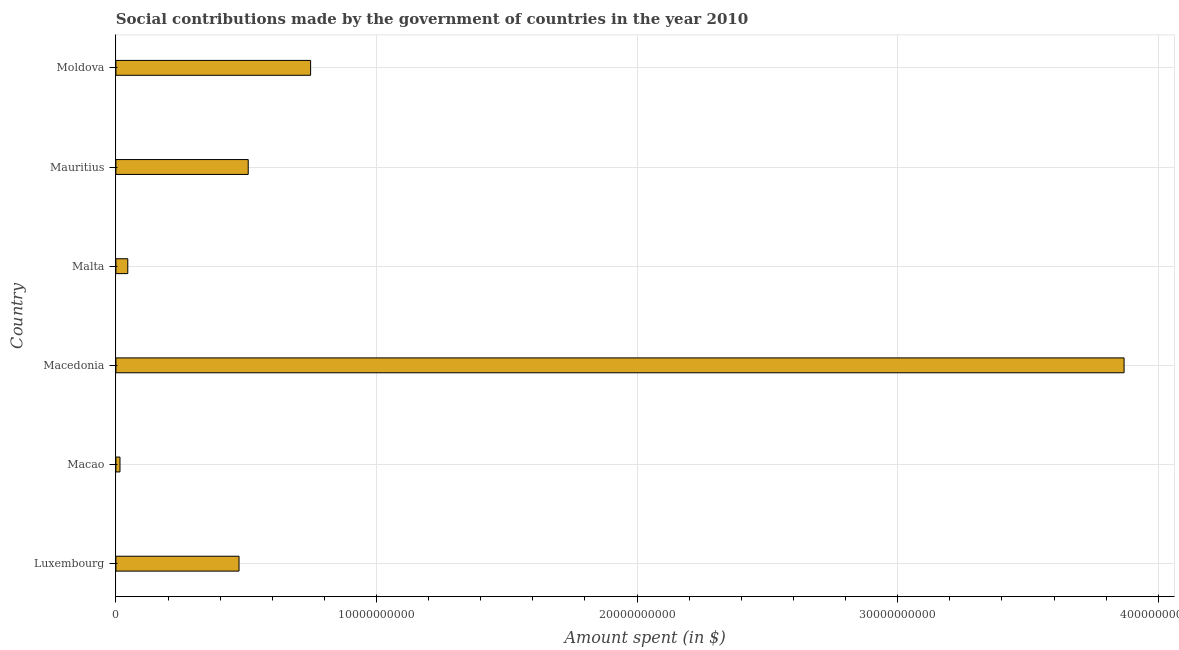What is the title of the graph?
Provide a succinct answer. Social contributions made by the government of countries in the year 2010. What is the label or title of the X-axis?
Keep it short and to the point. Amount spent (in $). What is the label or title of the Y-axis?
Give a very brief answer. Country. What is the amount spent in making social contributions in Malta?
Offer a terse response. 4.56e+08. Across all countries, what is the maximum amount spent in making social contributions?
Your answer should be very brief. 3.87e+1. Across all countries, what is the minimum amount spent in making social contributions?
Keep it short and to the point. 1.57e+08. In which country was the amount spent in making social contributions maximum?
Offer a terse response. Macedonia. In which country was the amount spent in making social contributions minimum?
Your answer should be compact. Macao. What is the sum of the amount spent in making social contributions?
Offer a terse response. 5.66e+1. What is the difference between the amount spent in making social contributions in Macao and Malta?
Offer a terse response. -2.99e+08. What is the average amount spent in making social contributions per country?
Provide a short and direct response. 9.43e+09. What is the median amount spent in making social contributions?
Offer a terse response. 4.90e+09. In how many countries, is the amount spent in making social contributions greater than 28000000000 $?
Give a very brief answer. 1. What is the ratio of the amount spent in making social contributions in Mauritius to that in Moldova?
Ensure brevity in your answer.  0.68. What is the difference between the highest and the second highest amount spent in making social contributions?
Offer a terse response. 3.12e+1. Is the sum of the amount spent in making social contributions in Luxembourg and Macedonia greater than the maximum amount spent in making social contributions across all countries?
Give a very brief answer. Yes. What is the difference between the highest and the lowest amount spent in making social contributions?
Give a very brief answer. 3.85e+1. How many countries are there in the graph?
Make the answer very short. 6. What is the Amount spent (in $) of Luxembourg?
Provide a short and direct response. 4.73e+09. What is the Amount spent (in $) of Macao?
Provide a succinct answer. 1.57e+08. What is the Amount spent (in $) in Macedonia?
Your answer should be very brief. 3.87e+1. What is the Amount spent (in $) of Malta?
Provide a short and direct response. 4.56e+08. What is the Amount spent (in $) of Mauritius?
Offer a very short reply. 5.08e+09. What is the Amount spent (in $) of Moldova?
Offer a terse response. 7.47e+09. What is the difference between the Amount spent (in $) in Luxembourg and Macao?
Provide a short and direct response. 4.57e+09. What is the difference between the Amount spent (in $) in Luxembourg and Macedonia?
Make the answer very short. -3.40e+1. What is the difference between the Amount spent (in $) in Luxembourg and Malta?
Make the answer very short. 4.27e+09. What is the difference between the Amount spent (in $) in Luxembourg and Mauritius?
Provide a short and direct response. -3.52e+08. What is the difference between the Amount spent (in $) in Luxembourg and Moldova?
Offer a very short reply. -2.75e+09. What is the difference between the Amount spent (in $) in Macao and Macedonia?
Your answer should be compact. -3.85e+1. What is the difference between the Amount spent (in $) in Macao and Malta?
Make the answer very short. -2.99e+08. What is the difference between the Amount spent (in $) in Macao and Mauritius?
Offer a terse response. -4.92e+09. What is the difference between the Amount spent (in $) in Macao and Moldova?
Your answer should be very brief. -7.31e+09. What is the difference between the Amount spent (in $) in Macedonia and Malta?
Your answer should be very brief. 3.82e+1. What is the difference between the Amount spent (in $) in Macedonia and Mauritius?
Offer a very short reply. 3.36e+1. What is the difference between the Amount spent (in $) in Macedonia and Moldova?
Your answer should be compact. 3.12e+1. What is the difference between the Amount spent (in $) in Malta and Mauritius?
Ensure brevity in your answer.  -4.62e+09. What is the difference between the Amount spent (in $) in Malta and Moldova?
Ensure brevity in your answer.  -7.02e+09. What is the difference between the Amount spent (in $) in Mauritius and Moldova?
Make the answer very short. -2.39e+09. What is the ratio of the Amount spent (in $) in Luxembourg to that in Macao?
Provide a succinct answer. 30.07. What is the ratio of the Amount spent (in $) in Luxembourg to that in Macedonia?
Provide a short and direct response. 0.12. What is the ratio of the Amount spent (in $) in Luxembourg to that in Malta?
Offer a very short reply. 10.35. What is the ratio of the Amount spent (in $) in Luxembourg to that in Moldova?
Offer a terse response. 0.63. What is the ratio of the Amount spent (in $) in Macao to that in Macedonia?
Your response must be concise. 0. What is the ratio of the Amount spent (in $) in Macao to that in Malta?
Offer a terse response. 0.34. What is the ratio of the Amount spent (in $) in Macao to that in Mauritius?
Ensure brevity in your answer.  0.03. What is the ratio of the Amount spent (in $) in Macao to that in Moldova?
Provide a succinct answer. 0.02. What is the ratio of the Amount spent (in $) in Macedonia to that in Malta?
Your answer should be compact. 84.77. What is the ratio of the Amount spent (in $) in Macedonia to that in Mauritius?
Provide a succinct answer. 7.62. What is the ratio of the Amount spent (in $) in Macedonia to that in Moldova?
Give a very brief answer. 5.18. What is the ratio of the Amount spent (in $) in Malta to that in Mauritius?
Offer a terse response. 0.09. What is the ratio of the Amount spent (in $) in Malta to that in Moldova?
Your answer should be compact. 0.06. What is the ratio of the Amount spent (in $) in Mauritius to that in Moldova?
Offer a very short reply. 0.68. 